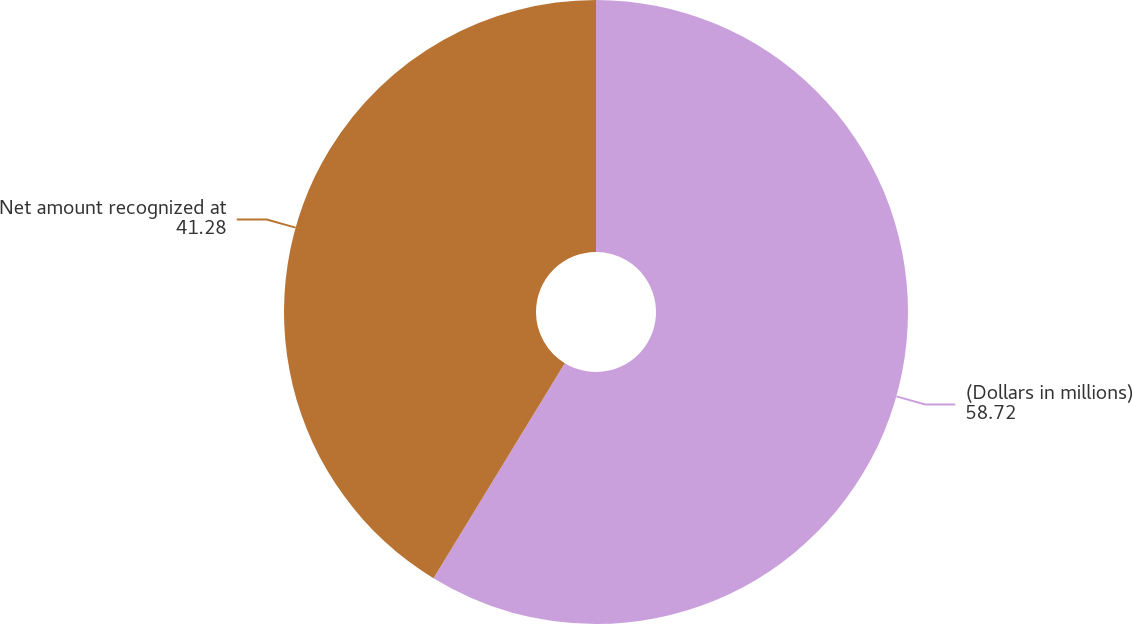Convert chart to OTSL. <chart><loc_0><loc_0><loc_500><loc_500><pie_chart><fcel>(Dollars in millions)<fcel>Net amount recognized at<nl><fcel>58.72%<fcel>41.28%<nl></chart> 